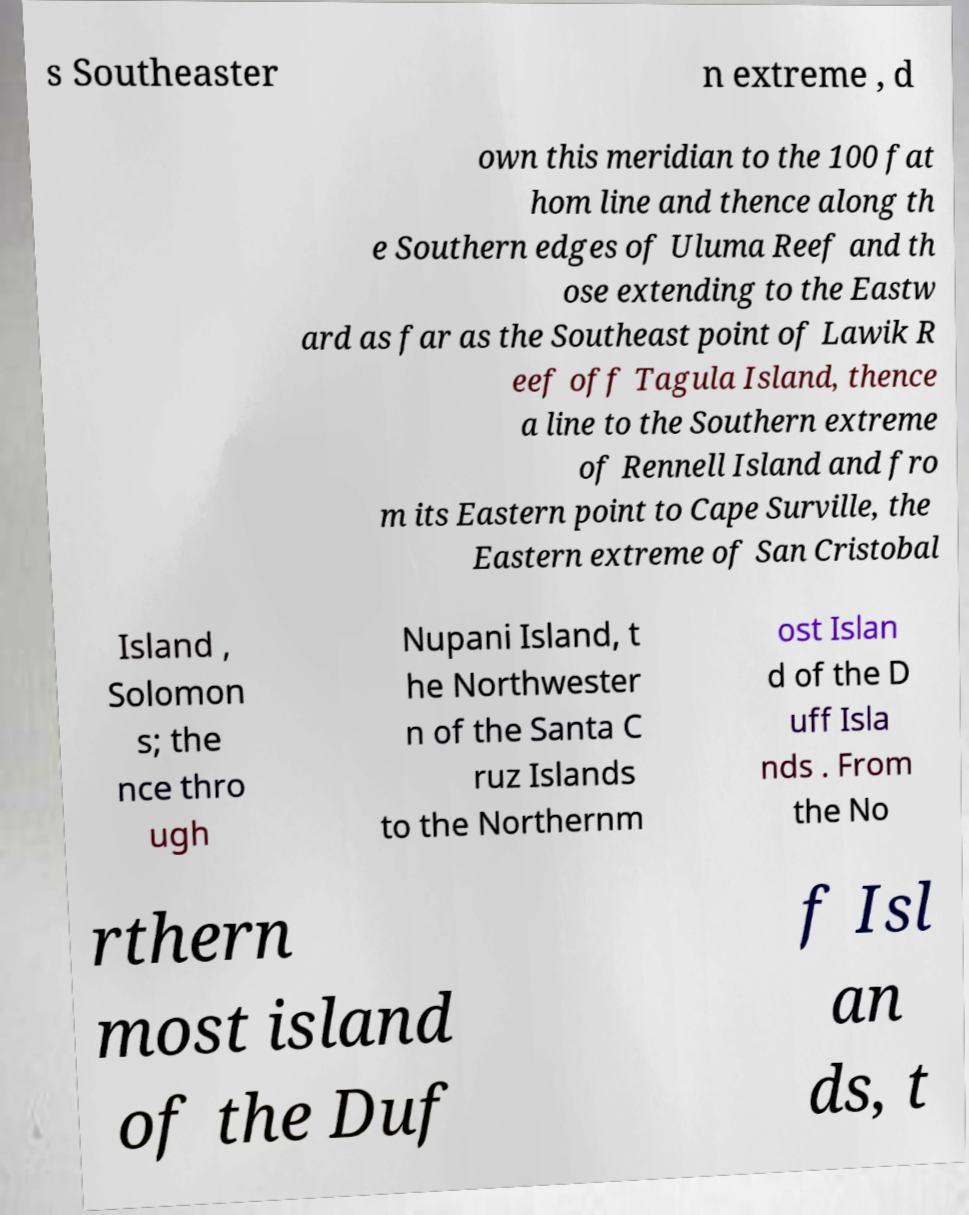Could you extract and type out the text from this image? s Southeaster n extreme , d own this meridian to the 100 fat hom line and thence along th e Southern edges of Uluma Reef and th ose extending to the Eastw ard as far as the Southeast point of Lawik R eef off Tagula Island, thence a line to the Southern extreme of Rennell Island and fro m its Eastern point to Cape Surville, the Eastern extreme of San Cristobal Island , Solomon s; the nce thro ugh Nupani Island, t he Northwester n of the Santa C ruz Islands to the Northernm ost Islan d of the D uff Isla nds . From the No rthern most island of the Duf f Isl an ds, t 